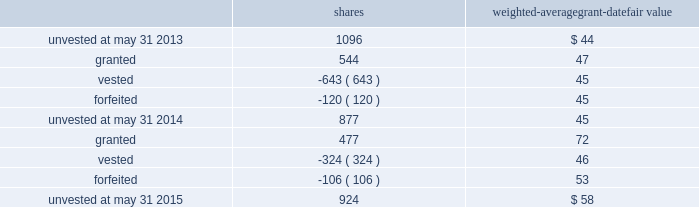The performance units granted to certain executives in fiscal 2014 were based on a one-year performance period .
After the compensation committee certified the performance results , 25% ( 25 % ) of the performance units converted to unrestricted shares .
The remaining 75% ( 75 % ) converted to restricted shares that vest in equal installments on each of the first three anniversaries of the conversion date .
The performance units granted to certain executives during fiscal 2015 were based on a three-year performance period .
After the compensation committee certifies the performance results for the three-year period , performance units earned will convert into unrestricted common stock .
The compensation committee may set a range of possible performance-based outcomes for performance units .
Depending on the achievement of the performance measures , the grantee may earn up to 200% ( 200 % ) of the target number of shares .
For awards with only performance conditions , we recognize compensation expense over the performance period using the grant date fair value of the award , which is based on the number of shares expected to be earned according to the level of achievement of performance goals .
If the number of shares expected to be earned were to change at any time during the performance period , we would make a cumulative adjustment to share-based compensation expense based on the revised number of shares expected to be earned .
During fiscal 2015 , certain executives were granted performance units that we refer to as leveraged performance units , or lpus .
Lpus contain a market condition based on our relative stock price growth over a three-year performance period .
The lpus contain a minimum threshold performance which , if not met , would result in no payout .
The lpus also contain a maximum award opportunity set as a fixed dollar and fixed number of shares .
After the three-year performance period , one-third of any earned units converts to unrestricted common stock .
The remaining two-thirds convert to restricted stock that will vest in equal installments on each of the first two anniversaries of the conversion date .
We recognize share-based compensation expense based on the grant date fair value of the lpus , as determined by use of a monte carlo model , on a straight-line basis over the requisite service period for each separately vesting portion of the lpu award .
Total shareholder return units before fiscal 2015 , certain of our executives were granted total shareholder return ( 201ctsr 201d ) units , which are performance-based restricted stock units that are earned based on our total shareholder return over a three-year performance period compared to companies in the s&p 500 .
Once the performance results are certified , tsr units convert into unrestricted common stock .
Depending on our performance , the grantee may earn up to 200% ( 200 % ) of the target number of shares .
The target number of tsr units for each executive is set by the compensation committee .
We recognize share-based compensation expense based on the grant date fair value of the tsr units , as determined by use of a monte carlo model , on a straight-line basis over the vesting period .
The table summarizes the changes in unvested share-based awards for the years ended may 31 , 2015 and 2014 ( shares in thousands ) : shares weighted-average grant-date fair value .
Global payments inc .
| 2015 form 10-k annual report 2013 81 .
What is the total value of the granted shares in 2014 , ( in thousands )? 
Computations: (544 * 47)
Answer: 25568.0. 